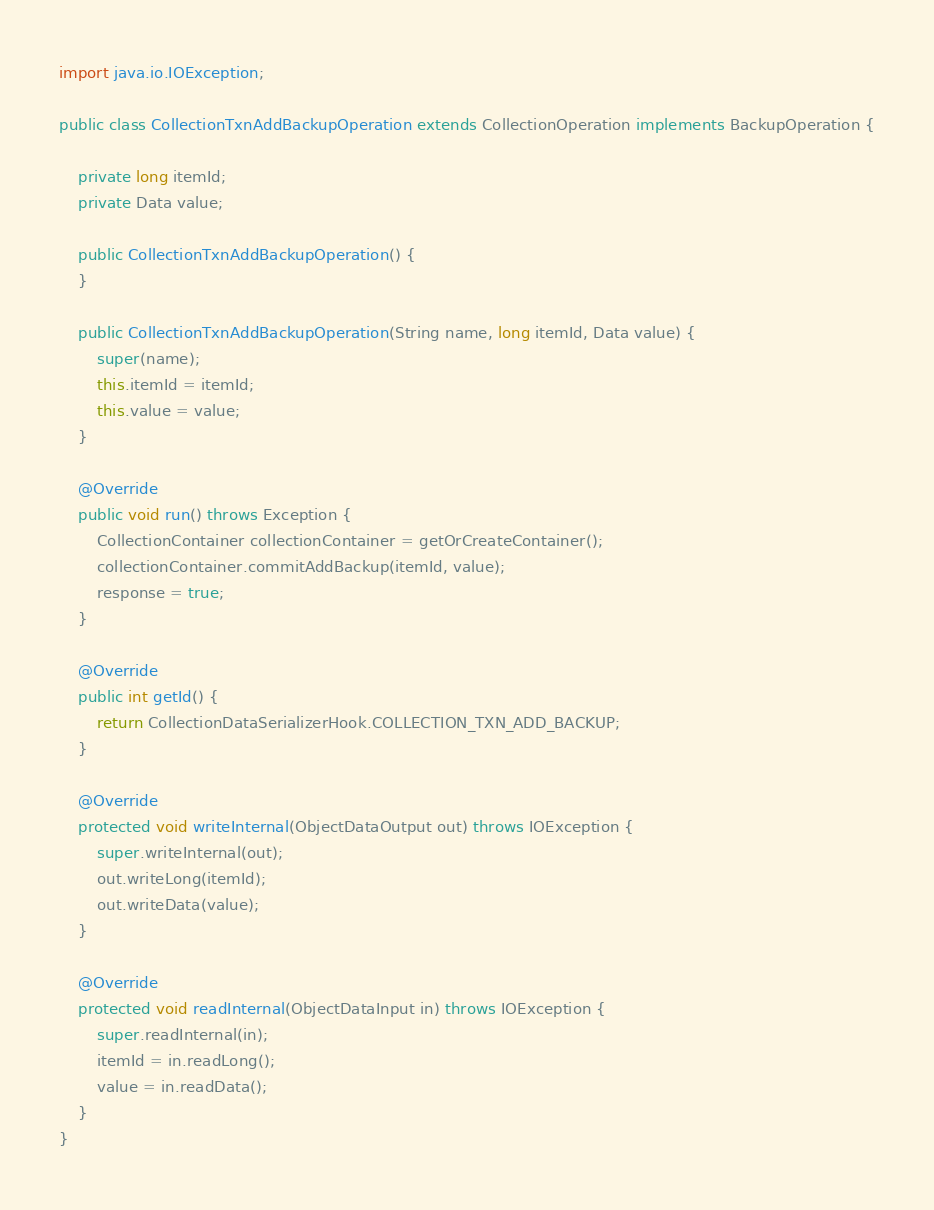<code> <loc_0><loc_0><loc_500><loc_500><_Java_>
import java.io.IOException;

public class CollectionTxnAddBackupOperation extends CollectionOperation implements BackupOperation {

    private long itemId;
    private Data value;

    public CollectionTxnAddBackupOperation() {
    }

    public CollectionTxnAddBackupOperation(String name, long itemId, Data value) {
        super(name);
        this.itemId = itemId;
        this.value = value;
    }

    @Override
    public void run() throws Exception {
        CollectionContainer collectionContainer = getOrCreateContainer();
        collectionContainer.commitAddBackup(itemId, value);
        response = true;
    }

    @Override
    public int getId() {
        return CollectionDataSerializerHook.COLLECTION_TXN_ADD_BACKUP;
    }

    @Override
    protected void writeInternal(ObjectDataOutput out) throws IOException {
        super.writeInternal(out);
        out.writeLong(itemId);
        out.writeData(value);
    }

    @Override
    protected void readInternal(ObjectDataInput in) throws IOException {
        super.readInternal(in);
        itemId = in.readLong();
        value = in.readData();
    }
}
</code> 